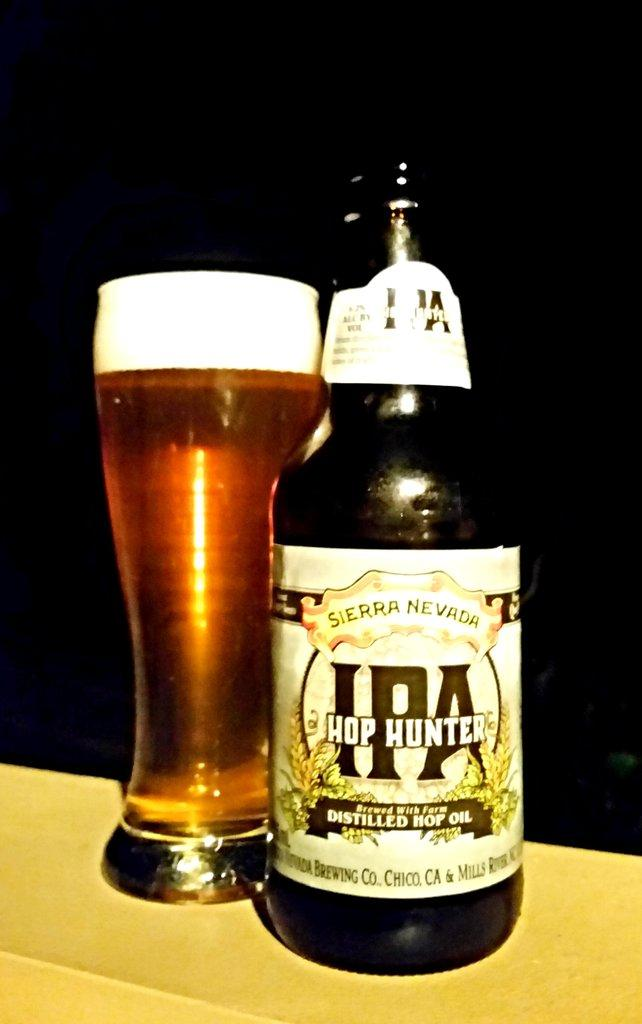<image>
Provide a brief description of the given image. A bottle of IPA Hop Hunter is served in a tall glass. 